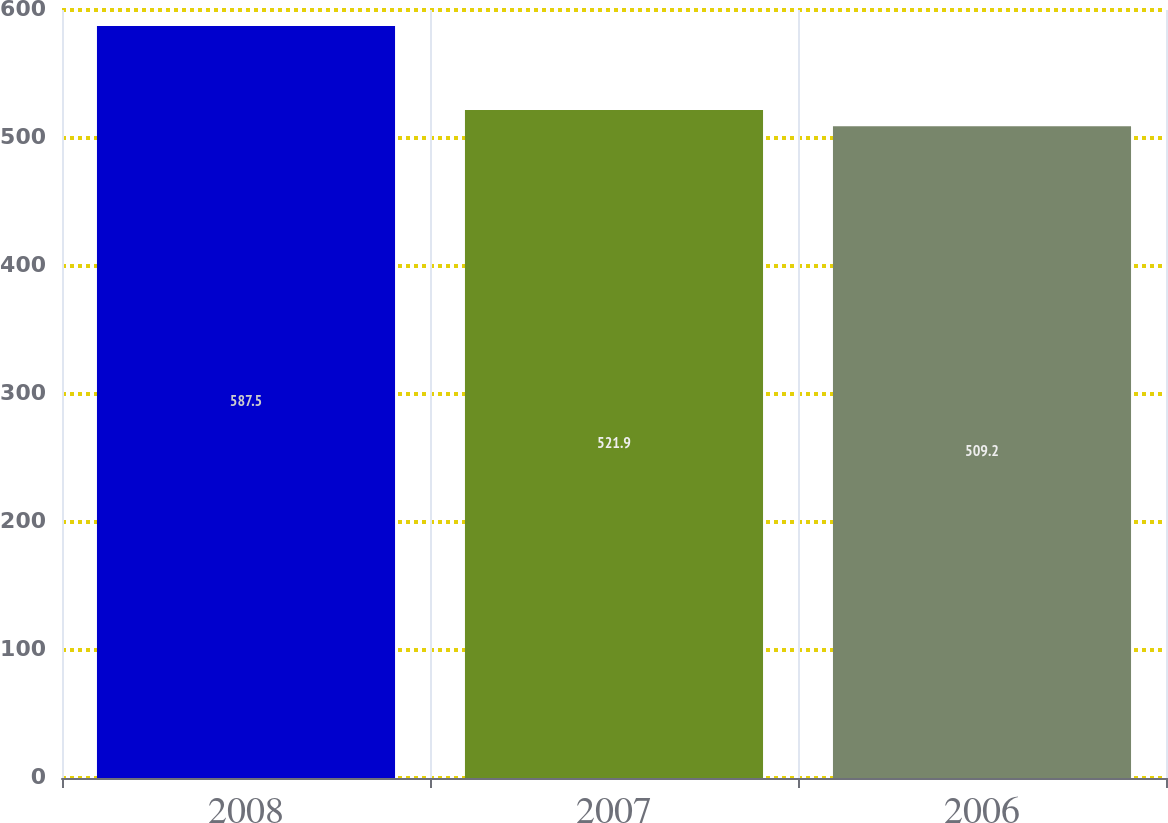Convert chart. <chart><loc_0><loc_0><loc_500><loc_500><bar_chart><fcel>2008<fcel>2007<fcel>2006<nl><fcel>587.5<fcel>521.9<fcel>509.2<nl></chart> 